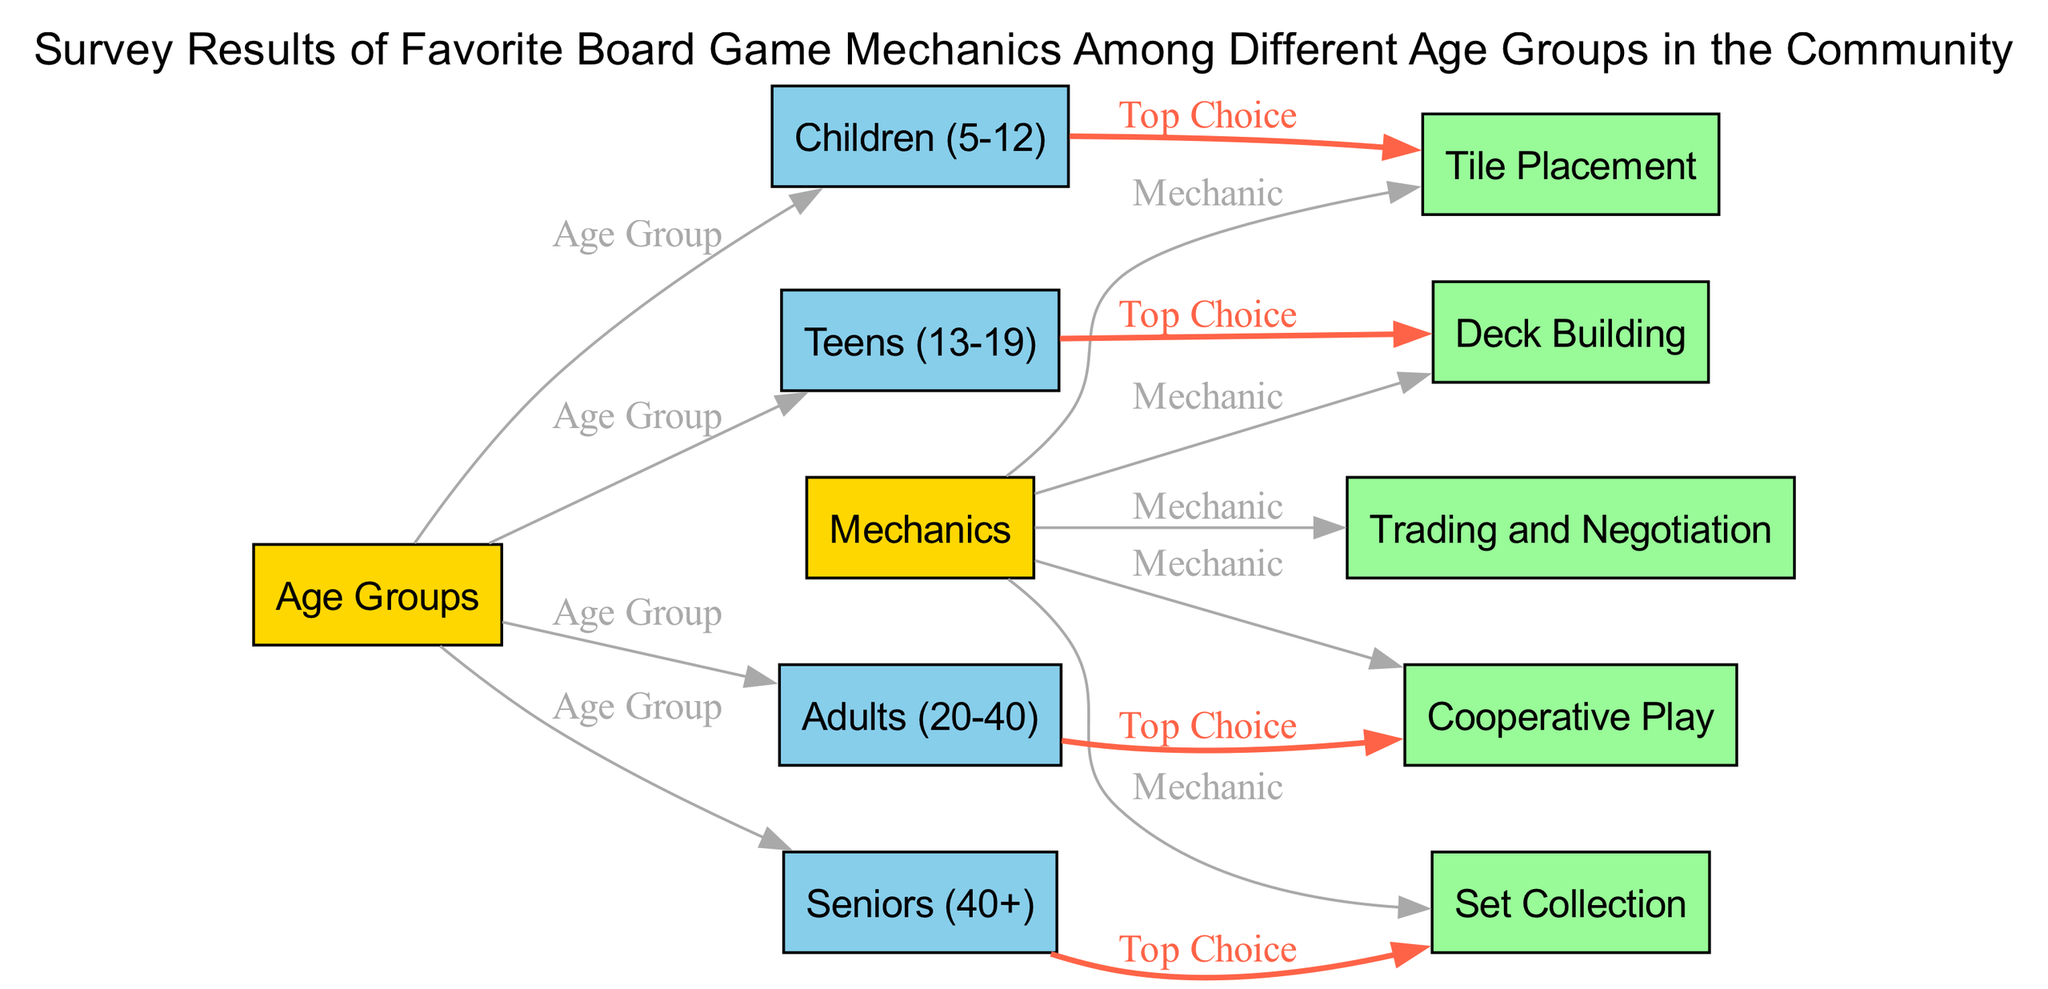What are the age groups included in the survey? The diagram lists four age groups: Children (5-12), Teens (13-19), Adults (20-40), and Seniors (40+). These are the main categories shown in the nodes labeled under "Age Groups."
Answer: Children (5-12), Teens (13-19), Adults (20-40), Seniors (40+) Which game mechanic is the top choice for Teens? According to the diagram, the edge connecting Teens (13-19) to Deck Building indicates that this is the preferred game mechanic for this age group.
Answer: Deck Building How many mechanics are listed in the diagram? The diagram presents five mechanics: Tile Placement, Deck Building, Cooperative Play, Set Collection, and Trading and Negotiation. This count is visible by counting the mechanics' nodes directly under "Mechanics."
Answer: 5 What is the top choice mechanic for Seniors? The edge connecting Seniors (40+) to Set Collection indicates that Set Collection is the preferred game mechanic for this group, as shown by the edge labeled "Top Choice."
Answer: Set Collection Which age group prefers Cooperative Play the most? This is determined by looking for the edge connecting an age group to Cooperative Play. According to the edges, there are no connections from any age group to Cooperative Play; therefore, it shows that no age group indicated it as a top choice.
Answer: None What is the relationship between Age Groups and Mechanics in this diagram? The diagram demonstrates a relationship where each age group is linked to a specific mechanic through edges that categorize their top choices. The edges illustrate that each age group has a distinct mechanic preference.
Answer: One-to-one relationships Which mechanic is the top choice for Adults? By reviewing the diagram, the edge links Adults (20-40) to Cooperative Play, confirming that this is their favorite game mechanic as shown directly in the labeled edge.
Answer: Cooperative Play How many edges connect the Age Groups to their respective Mechanics? By examining the edges in the diagram, there are four unique connections from the Age Groups to their specific mechanics, each representing a marked preference.
Answer: 4 